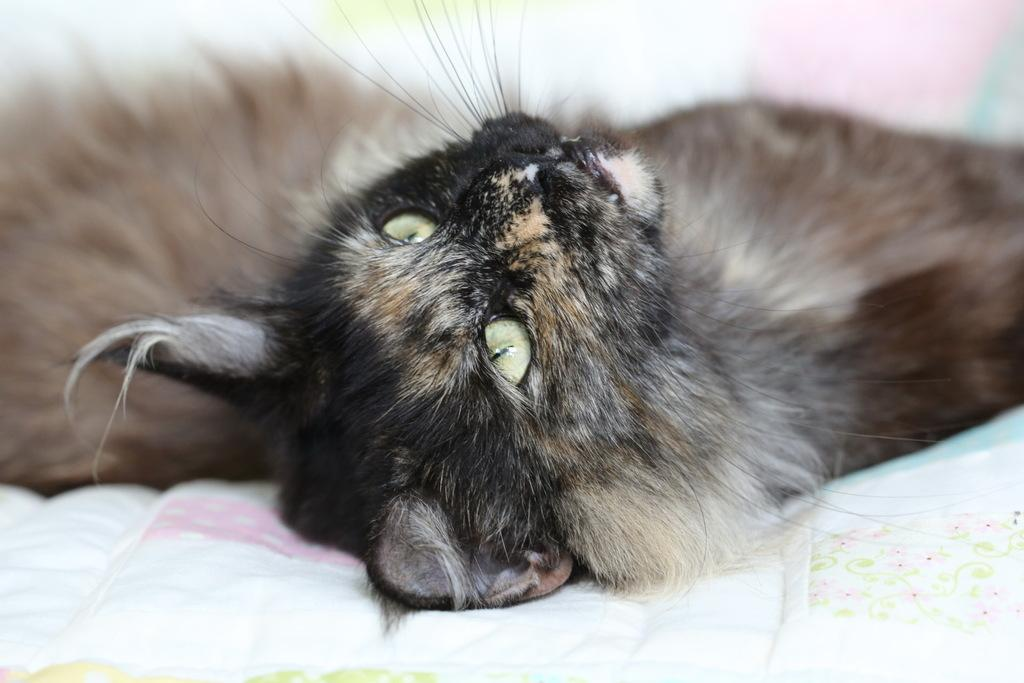What type of animal is in the image? There is a cat in the image. Where is the cat located? The cat is on the bed. What colors can be seen on the cat? The cat is black and brown in color. What is the distance between the cat and the aftermath of the week in the image? There is no distance mentioned in the image, nor is there any reference to an aftermath or a specific week. 